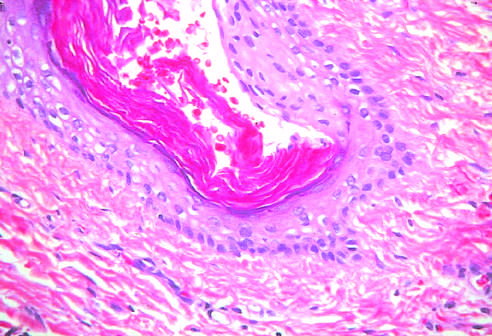do testicular teratomas contain mature cells from endodermal, mesodermal, and ectodermal lines?
Answer the question using a single word or phrase. Yes 